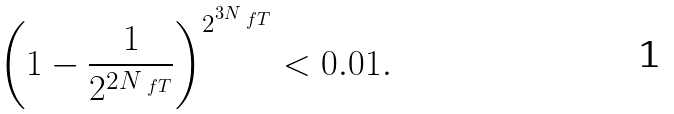<formula> <loc_0><loc_0><loc_500><loc_500>\left ( 1 - \frac { 1 } { 2 ^ { 2 N _ { \ f T } } } \right ) ^ { 2 ^ { 3 N _ { \ f T } } } < 0 . 0 1 .</formula> 